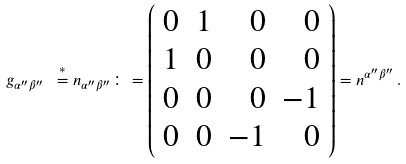<formula> <loc_0><loc_0><loc_500><loc_500>g _ { \alpha ^ { \prime \prime } \beta ^ { \prime \prime } } \ \stackrel { * } { = } n _ { \alpha ^ { \prime \prime } \beta ^ { \prime \prime } } \colon = \left ( \begin{array} { c c r r } 0 & 1 & 0 & 0 \\ 1 & 0 & 0 & 0 \\ 0 & 0 & 0 & - 1 \\ 0 & 0 & - 1 & 0 \end{array} \right ) = n ^ { \alpha ^ { \prime \prime } \beta ^ { \prime \prime } } \, .</formula> 